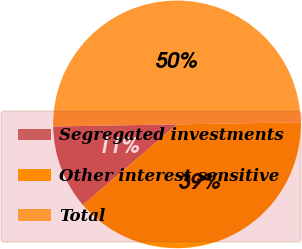Convert chart to OTSL. <chart><loc_0><loc_0><loc_500><loc_500><pie_chart><fcel>Segregated investments<fcel>Other interest sensitive<fcel>Total<nl><fcel>11.01%<fcel>38.99%<fcel>50.0%<nl></chart> 